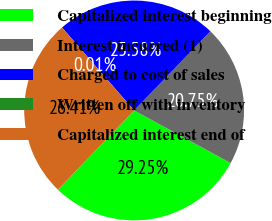<chart> <loc_0><loc_0><loc_500><loc_500><pie_chart><fcel>Capitalized interest beginning<fcel>Interest incurred (1)<fcel>Charged to cost of sales<fcel>Written off with inventory<fcel>Capitalized interest end of<nl><fcel>29.25%<fcel>20.75%<fcel>23.58%<fcel>0.01%<fcel>26.41%<nl></chart> 